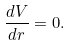<formula> <loc_0><loc_0><loc_500><loc_500>\frac { d V } { d r } = 0 .</formula> 